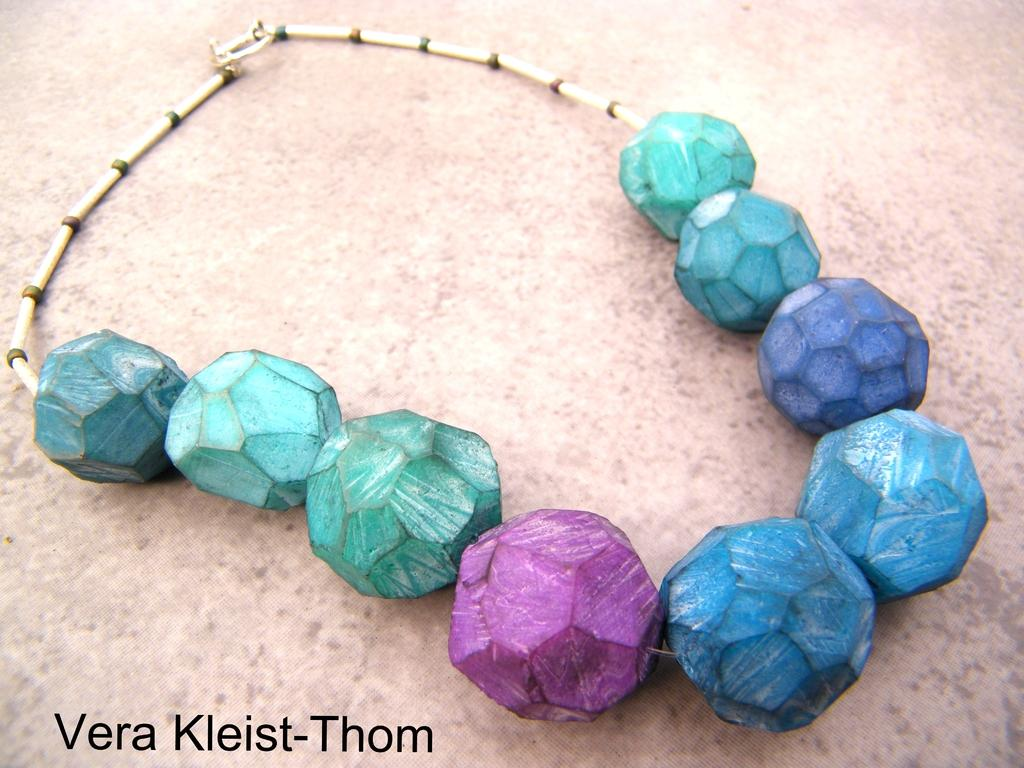What type of jewelry is in the image? There is a multicolored necklace in the image. Where is the necklace located? The necklace is on a surface. Is there any text present in the image? Yes, there is text visible at the bottom of the image. Can you see any steam coming from the necklace in the image? No, there is no steam present in the image. 